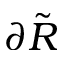Convert formula to latex. <formula><loc_0><loc_0><loc_500><loc_500>\partial \tilde { R }</formula> 